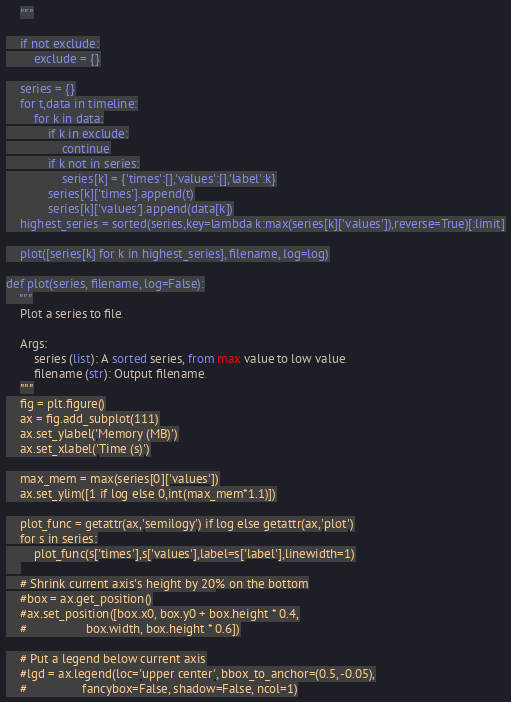Convert code to text. <code><loc_0><loc_0><loc_500><loc_500><_Python_>    """

    if not exclude:
        exclude = {}

    series = {}
    for t,data in timeline:
        for k in data:
            if k in exclude:
                continue
            if k not in series:
                series[k] = {'times':[],'values':[],'label':k}
            series[k]['times'].append(t)
            series[k]['values'].append(data[k])
    highest_series = sorted(series,key=lambda k:max(series[k]['values']),reverse=True)[:limit]

    plot([series[k] for k in highest_series], filename, log=log)

def plot(series, filename, log=False):
    """
    Plot a series to file.

    Args:
        series (list): A sorted series, from max value to low value.
        filename (str): Output filename.
    """
    fig = plt.figure()
    ax = fig.add_subplot(111)
    ax.set_ylabel('Memory (MB)')
    ax.set_xlabel('Time (s)')

    max_mem = max(series[0]['values'])
    ax.set_ylim([1 if log else 0,int(max_mem*1.1)])

    plot_func = getattr(ax,'semilogy') if log else getattr(ax,'plot')
    for s in series:
        plot_func(s['times'],s['values'],label=s['label'],linewidth=1)
    
    # Shrink current axis's height by 20% on the bottom
    #box = ax.get_position()
    #ax.set_position([box.x0, box.y0 + box.height * 0.4,
    #                 box.width, box.height * 0.6])

    # Put a legend below current axis
    #lgd = ax.legend(loc='upper center', bbox_to_anchor=(0.5, -0.05),
    #                fancybox=False, shadow=False, ncol=1)</code> 